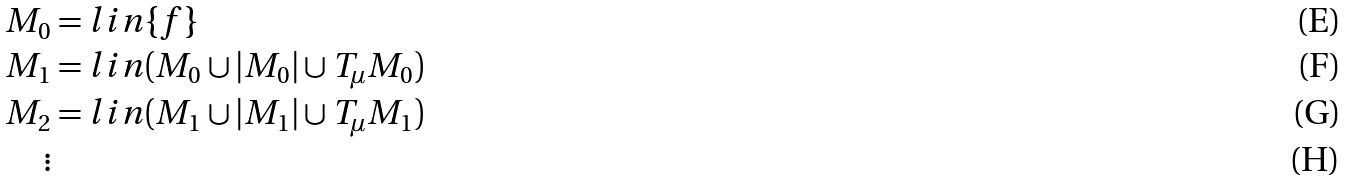<formula> <loc_0><loc_0><loc_500><loc_500>M _ { 0 } & = l i n \{ f \} \\ M _ { 1 } & = l i n ( M _ { 0 } \cup | M _ { 0 } | \cup T _ { \mu } M _ { 0 } ) \\ M _ { 2 } & = l i n ( M _ { 1 } \cup | M _ { 1 } | \cup T _ { \mu } M _ { 1 } ) \\ \vdots</formula> 